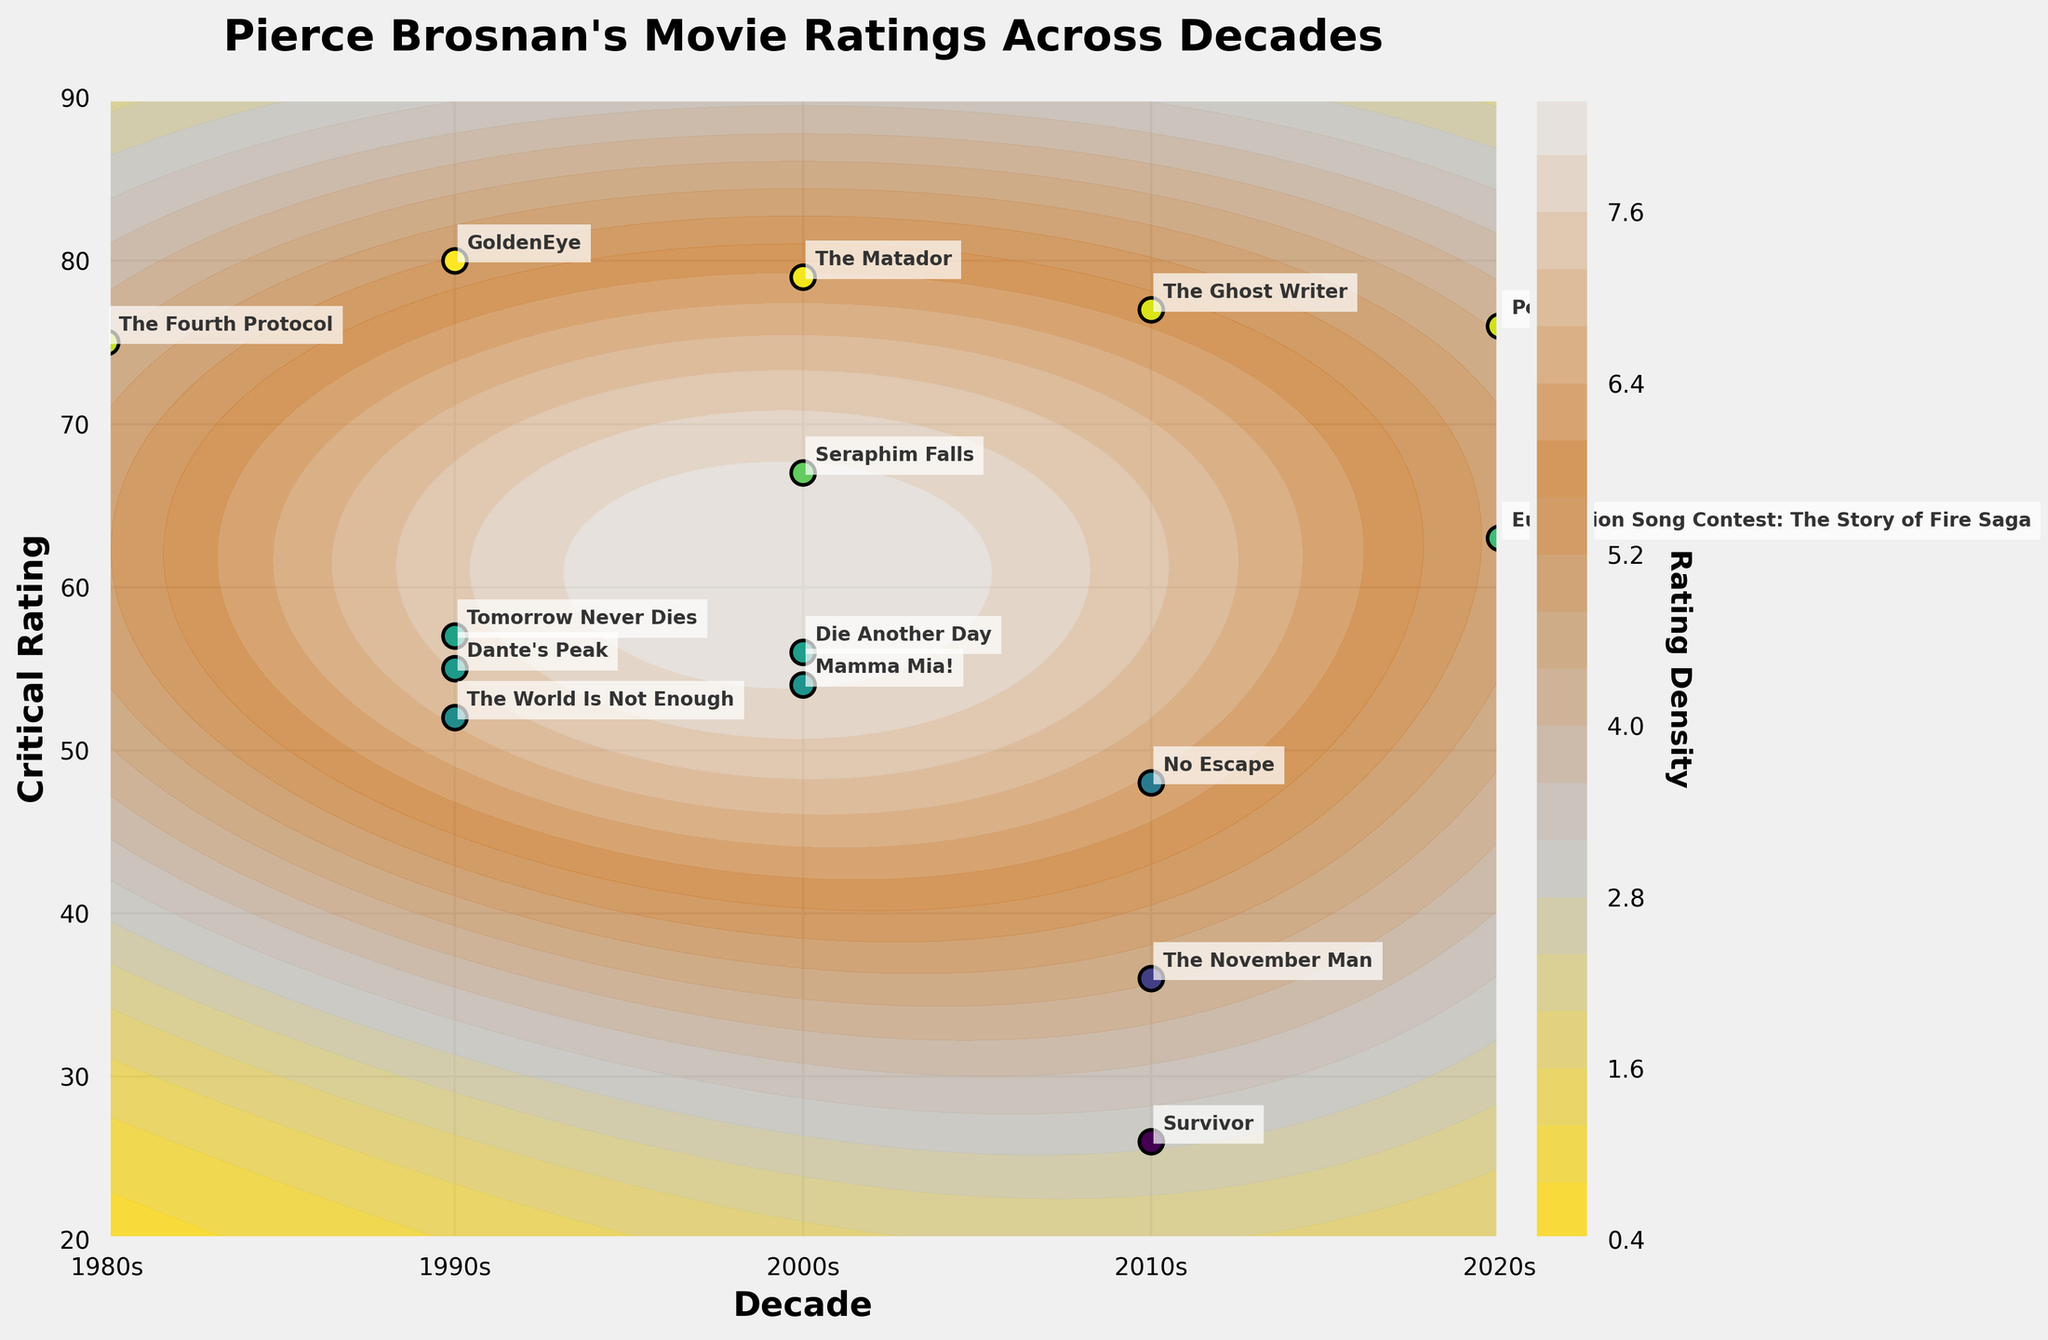What is the title of the plot? The title is typically located at the top of the figure in a larger font. It summarizes the main theme of the plot. Here, it is given as "Pierce Brosnan's Movie Ratings Across Decades".
Answer: Pierce Brosnan's Movie Ratings Across Decades What is the critical rating of "The November Man"? Find "The November Man" labeled on the plot. Its position on the vertical axis (Rating) indicates its critical rating. It is positioned at a critical rating of 36.
Answer: 36 Which decade has the highest density of higher critical ratings? The higher density is indicated by more closely packed contour lines or darker shaded regions in the plot. The 2000s show a dense concentration of higher ratings.
Answer: 2000s How many movies from the 1990s are labeled in the plot? Look at the labels and count movies within the region specified for the 1990s on the x-axis. The labels are GoldenEye, Dante's Peak, Tomorrow Never Dies, and The World Is Not Enough.
Answer: 4 Which movie has the highest critical rating, and what is it? Identify the movie labeled at the highest point on the vertical axis (Rating). "GoldenEye" is at the highest rating with a score of 80.
Answer: GoldenEye, 80 Compare the critical rating of "Seraphim Falls" and "Eurovision Song Contest: The Story of Fire Saga". Which one is higher? Locate both movies on the plot and compare their positions on the vertical axis. "Seraphim Falls" has a rating of 67 and "Eurovision Song Contest: The Story of Fire Saga" has a rating of 63.
Answer: Seraphim Falls What is the average critical rating of Pierce Brosnan's movies in the 2010s? Find and sum the critical ratings of all movies in the 2010s and divide by the number of movies. Movies are: The November Man (36), The Ghost Writer (77), Survivor (26), and No Escape (48). Calculation: (36 + 77 + 26 + 48) / 4 = 187 / 4 = 46.75
Answer: 46.75 Which decade contains a movie with the lowest critical rating? Identify the movie with the lowest rating on the vertical axis and note its decade. "Survivor" in the 2010s has the lowest rating of 26.
Answer: 2010s Is the rating density higher for the 2020s or the 1980s? Compare the density of contour lines or shaded areas between the 2020s and 1980s regions on the plot. The plot shows a higher density in the 2020s compared to the 1980s.
Answer: 2020s How does "Dante's Peak" rating compare to "Mamma Mia!"? Locate both "Dante's Peak" and "Mamma Mia!" on the plot. Compare their positions on the vertical axis. "Dante's Peak" has a higher rating (55) than "Mamma Mia!" (54).
Answer: Dante's Peak is higher 